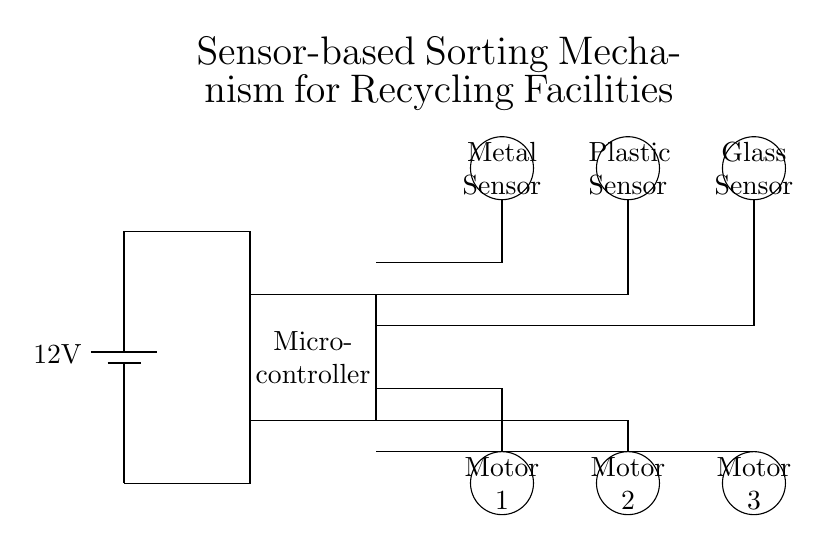What is the voltage supply for the circuit? The circuit diagram indicates a battery labeled with a voltage of 12 volts, which is the power supply for the entire setup.
Answer: 12 volts What type of sensors are used in this circuit? The diagram shows three circular sensors labeled as Metal Sensor, Plastic Sensor, and Glass Sensor. These identify different materials for sorting.
Answer: Metal, Plastic, Glass How many motors are connected to the microcontroller? There are three motors depicted in the diagram, which are connected to the microcontroller for sorting the materials identified by the sensors.
Answer: Three Which component connects the sensors to the sorting motors? The microcontroller acts as the intermediary in the circuit; it processes the information from the sensors and controls the operation of the motors based on that input.
Answer: Microcontroller What is the role of the microcontroller in this circuit? The microcontroller receives input from the sensors about the type of material detected and then sends signals to the corresponding motor to sort the materials appropriately.
Answer: Control sorting Which sensor is located furthest to the right in the diagram? The diagram shows the Glass Sensor as the rightmost sensor, positioned at the far right side of the sensor arrangement.
Answer: Glass Sensor 